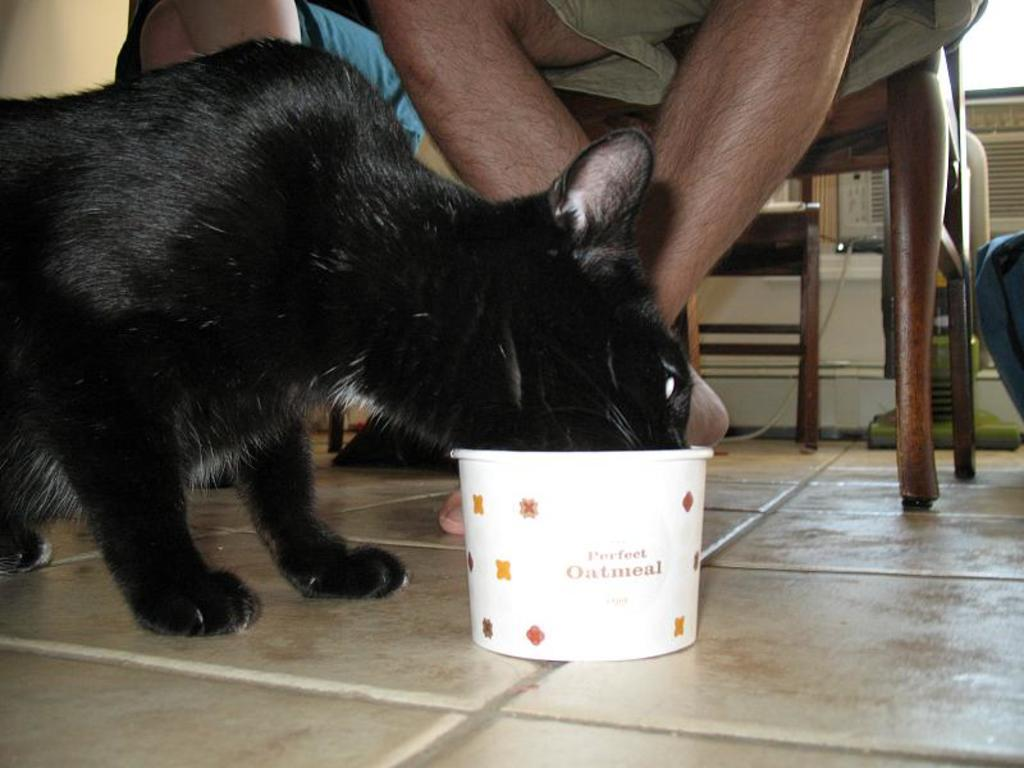What type of animal is present in the image? There is a cat in the image. What object can be seen on the floor in the image? There is a bowl on the floor in the image. What are the persons in the image doing? The persons in the image are sitting on chairs. What type of suit is the friend wearing in the image? There is no friend or suit present in the image; it features a cat, a bowl on the floor, and persons sitting on chairs. What items are on the list that can be seen in the image? There is no list present in the image. 